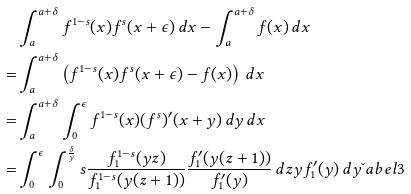Convert formula to latex. <formula><loc_0><loc_0><loc_500><loc_500>& \int _ { a } ^ { a + \delta } f ^ { 1 - s } ( x ) f ^ { s } ( x + \epsilon ) \, d x - \int _ { a } ^ { a + \delta } f ( x ) \, d x \\ = & \int _ { a } ^ { a + \delta } \left ( f ^ { 1 - s } ( x ) f ^ { s } ( x + \epsilon ) - f ( x ) \right ) \, d x \\ = & \int _ { a } ^ { a + \delta } \int _ { 0 } ^ { \epsilon } f ^ { 1 - s } ( x ) ( f ^ { s } ) ^ { \prime } ( x + y ) \, d y \, d x \\ = & \int _ { 0 } ^ { \epsilon } \int _ { 0 } ^ { \frac { \delta } { y } } s \frac { f _ { 1 } ^ { 1 - s } ( y z ) } { f _ { 1 } ^ { 1 - s } ( y ( z + 1 ) ) } \frac { f _ { 1 } ^ { \prime } ( y ( z + 1 ) ) } { f _ { 1 } ^ { \prime } ( y ) } \, d z y f _ { 1 } ^ { \prime } ( y ) \, d y \L a b e l { 3 }</formula> 